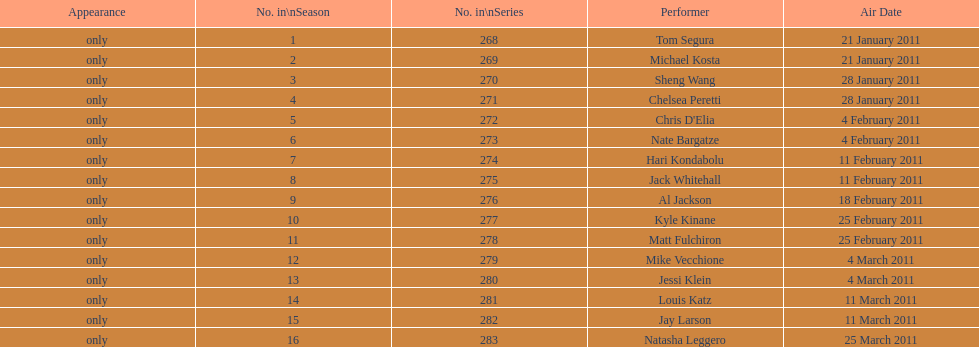What were the total number of air dates in february? 7. 